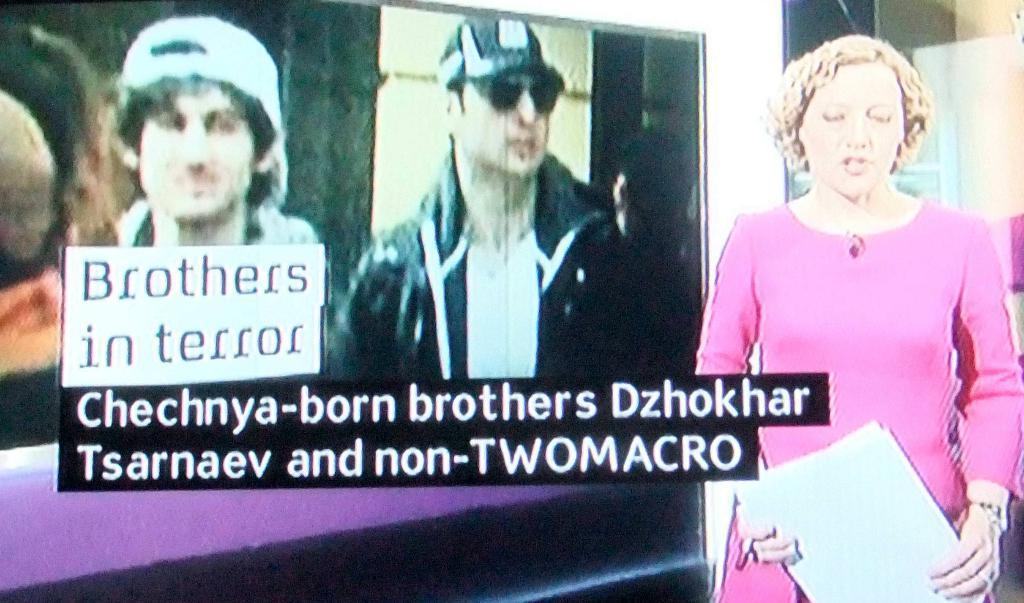In one or two sentences, can you explain what this image depicts? In this picture I can see a woman standing and holding papers, side we can see a screen on which we can see a person and some text. 